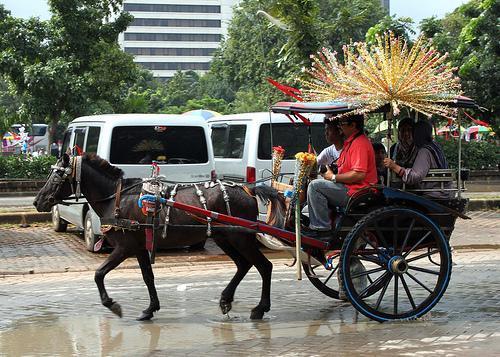How many people are in the cart?
Give a very brief answer. 5. 